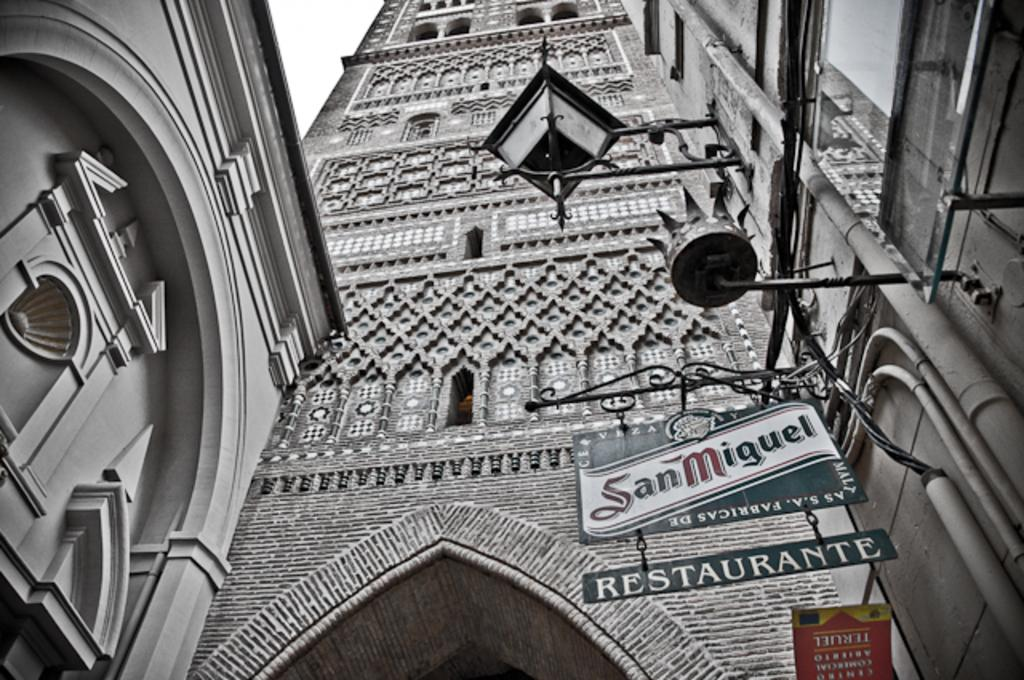What is the main object in the image? There is a sign board in the image. What other objects can be seen in the image? There is a lamp and buildings in the image. How many eggs are on the sign board in the image? There are no eggs present on the sign board or in the image. 